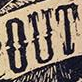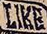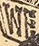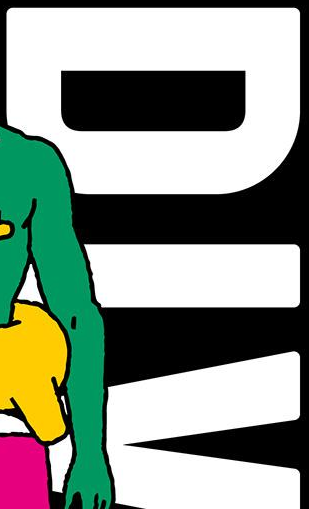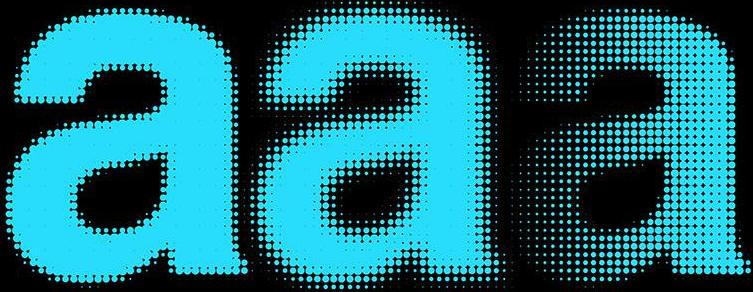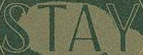Read the text content from these images in order, separated by a semicolon. OUT; LIKE; WE; DIV; aaa; STAY 